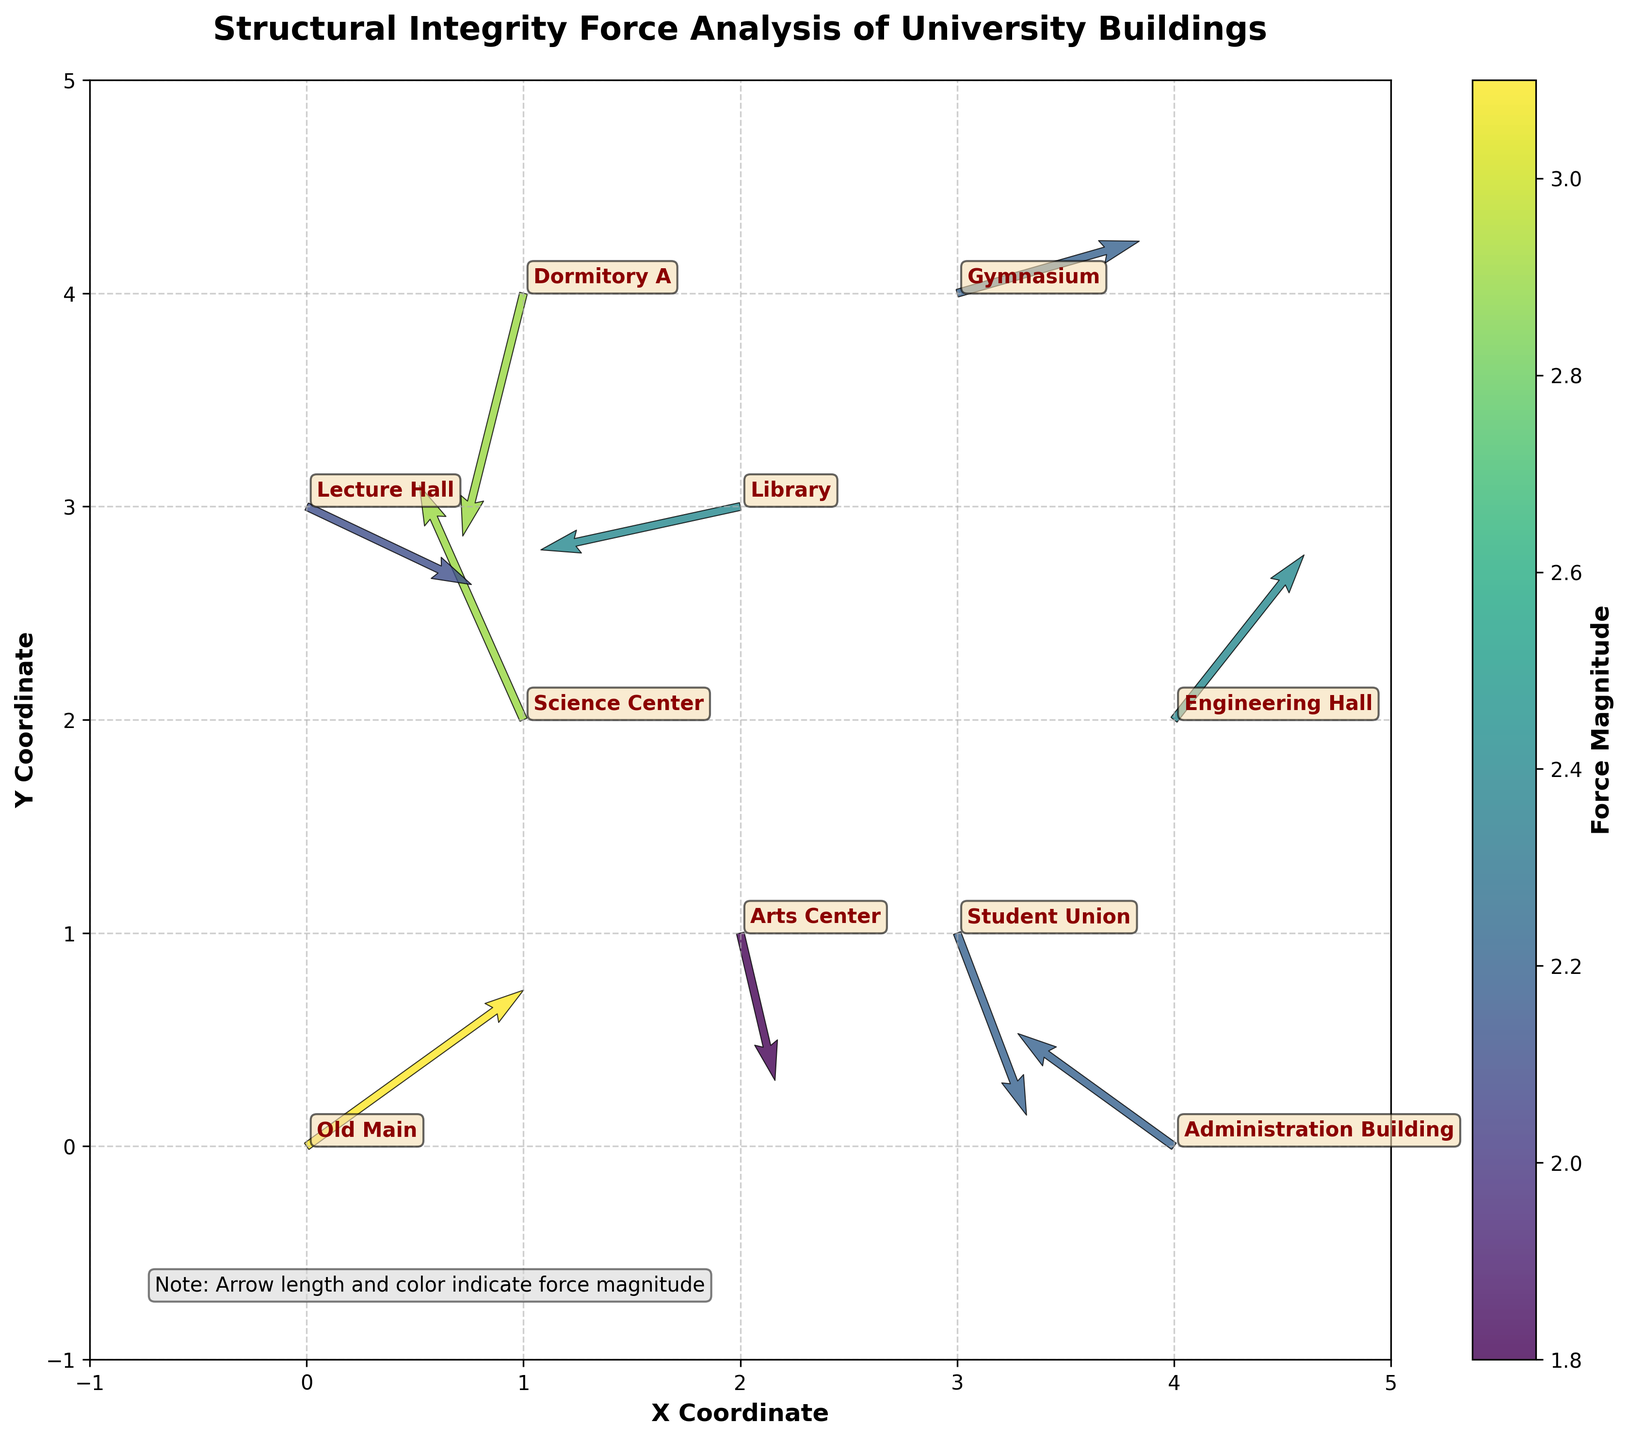What is the title of the plot? The title is usually displayed at the top of the figure and often gives a summary of what the plot is about. In this figure, it is written in bold to get attention.
Answer: Structural Integrity Force Analysis of University Buildings How many buildings are analyzed in this study? By counting the annotations or labels within the plot, we can determine the total number of buildings considered in this study. Each label corresponds to a building.
Answer: 10 Which building has the highest force magnitude? The color intensity and length of the arrows in the quiver plot indicate force magnitude. By cross-referencing the color bar, we see that the building with the highest force magnitude is shaded most intensely.
Answer: Old Main What are the X and Y coordinates of the Library? We locate the Library annotation in the plot. The position of this annotation corresponds to the X and Y coordinates of the Library.
Answer: (2, 3) Between Science Center and Administration Building, which one has a higher force magnitude? By locating the annotations for Science Center and Administration Building and comparing their arrow colors and lengths, we can determine which has a higher force magnitude.
Answer: Science Center Which direction does the force vector for the Arts Center point? By looking at the vector (arrow) for Arts Center and noting the direction it points (considering both X and Y components), we can describe its direction.
Answer: Downwards What is the range of X-axis and Y-axis in the plot? The limits of the plot are indicated by the axis bounds. By looking at where the plot begins and ends on both the X and Y axes, we can determine the range.
Answer: X-axis: -1 to 5, Y-axis: -1 to 5 What is the average force magnitude of all the buildings? First, sum up the force magnitudes of all the buildings and then divide by the total number of buildings to get the average force magnitude.
Answer: (3.1 + 2.9 + 2.2 + 2.4 + 2.4 + 2.9 + 2.2 + 2.2 + 1.8 + 2.1) / 10 = 2.42 Which building experiences a force vector pointing primarily to the left? By examining the vector directions, identify the one with a significant negative X-component. The building associated with this vector has a force pointing primarily leftward.
Answer: Library Which building's force direction is mostly aligned with the positive X-axis? We need to find the building where the force vector has a positive X-component that is significantly larger than the Y-component or points in the X direction.
Answer: Gymnasium 